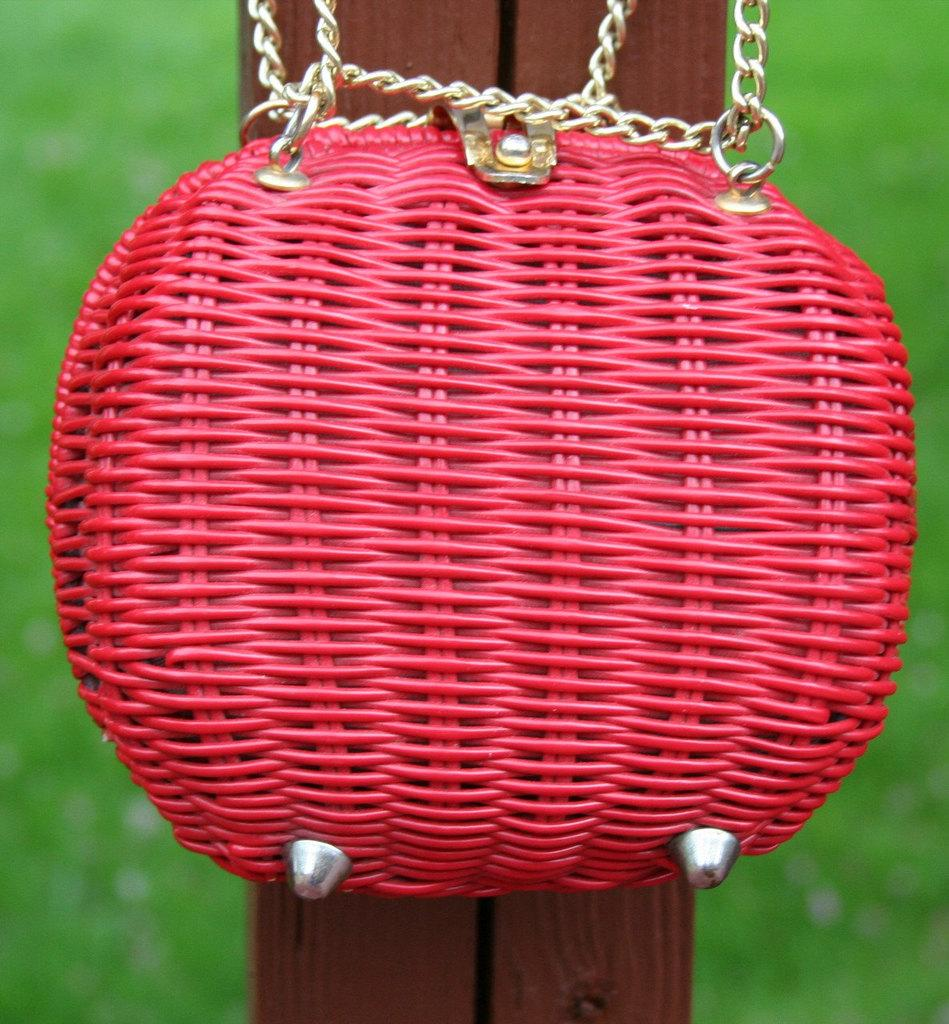What object is made of wood in the image? There is a wooden stick in the image. What is attached to the wooden stick? A red color bag is attached to the wooden stick. What is connected to the red color bag? Chains are connected to the red color bag. What type of vegetation is visible in the background of the image? There is green grass in the background of the image. What type of scissors can be seen cutting the grass in the image? There are no scissors present in the image, and the grass is not being cut. 